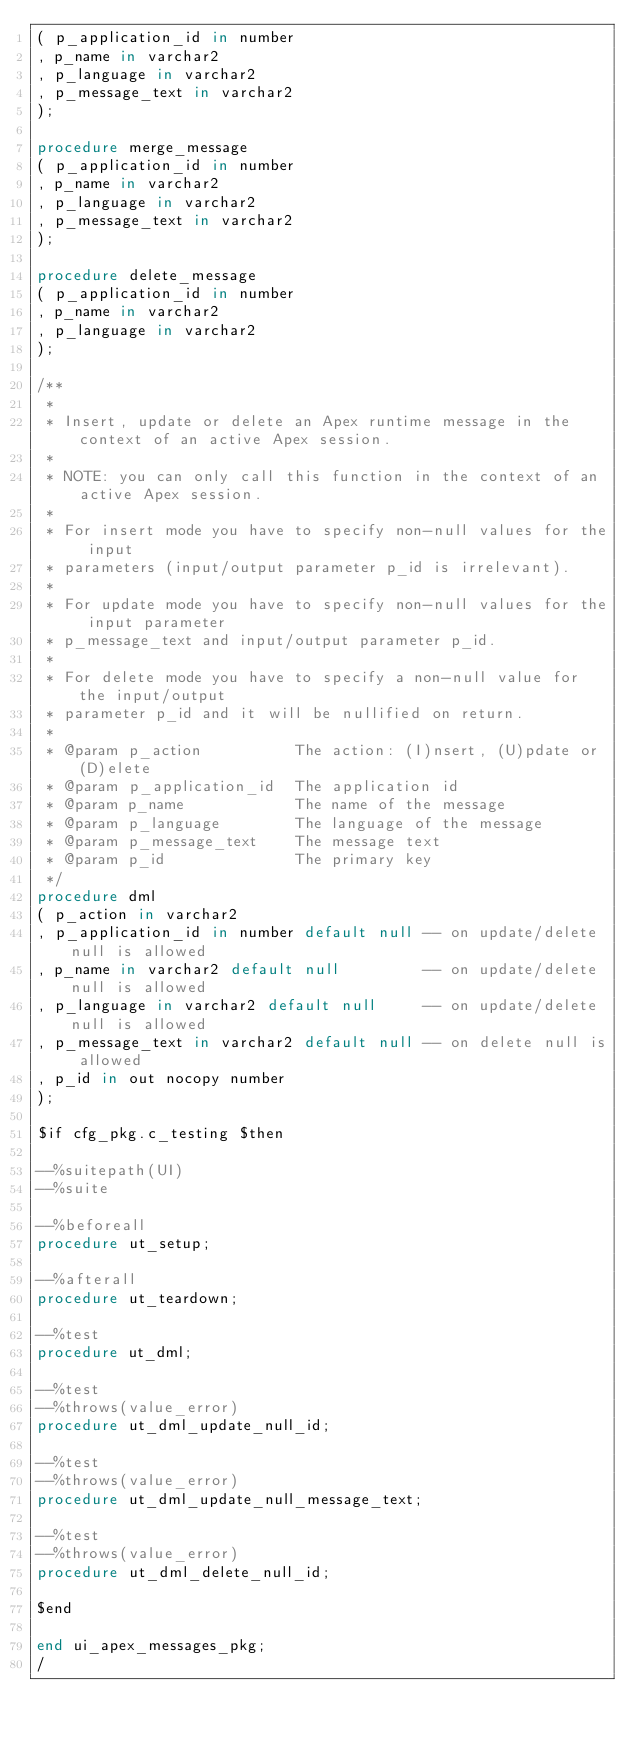<code> <loc_0><loc_0><loc_500><loc_500><_SQL_>( p_application_id in number
, p_name in varchar2
, p_language in varchar2
, p_message_text in varchar2
);
  
procedure merge_message
( p_application_id in number
, p_name in varchar2
, p_language in varchar2
, p_message_text in varchar2
);
  
procedure delete_message
( p_application_id in number
, p_name in varchar2
, p_language in varchar2
);

/**
 *
 * Insert, update or delete an Apex runtime message in the context of an active Apex session.
 *
 * NOTE: you can only call this function in the context of an active Apex session.
 *
 * For insert mode you have to specify non-null values for the input
 * parameters (input/output parameter p_id is irrelevant).
 *
 * For update mode you have to specify non-null values for the input parameter
 * p_message_text and input/output parameter p_id.
 *
 * For delete mode you have to specify a non-null value for the input/output
 * parameter p_id and it will be nullified on return.
 *
 * @param p_action          The action: (I)nsert, (U)pdate or (D)elete
 * @param p_application_id  The application id
 * @param p_name            The name of the message
 * @param p_language        The language of the message
 * @param p_message_text    The message text
 * @param p_id              The primary key
 */
procedure dml
( p_action in varchar2
, p_application_id in number default null -- on update/delete null is allowed
, p_name in varchar2 default null         -- on update/delete null is allowed
, p_language in varchar2 default null     -- on update/delete null is allowed
, p_message_text in varchar2 default null -- on delete null is allowed
, p_id in out nocopy number
);  

$if cfg_pkg.c_testing $then

--%suitepath(UI)
--%suite

--%beforeall
procedure ut_setup;

--%afterall
procedure ut_teardown;

--%test
procedure ut_dml;

--%test
--%throws(value_error)
procedure ut_dml_update_null_id;

--%test
--%throws(value_error)
procedure ut_dml_update_null_message_text;

--%test
--%throws(value_error)
procedure ut_dml_delete_null_id;

$end

end ui_apex_messages_pkg;
/
</code> 